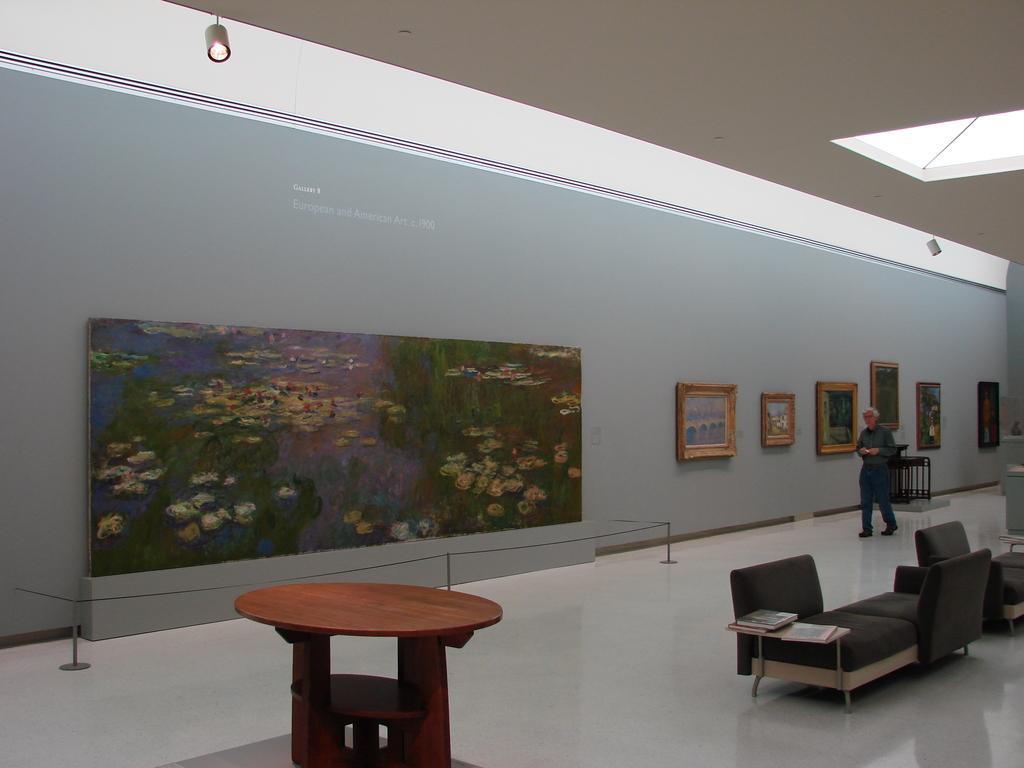How would you summarize this image in a sentence or two? An old man is passing by paintings in a gallery. 